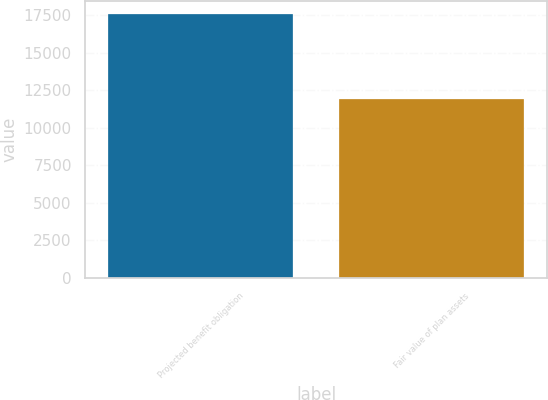Convert chart to OTSL. <chart><loc_0><loc_0><loc_500><loc_500><bar_chart><fcel>Projected benefit obligation<fcel>Fair value of plan assets<nl><fcel>17570<fcel>11934<nl></chart> 